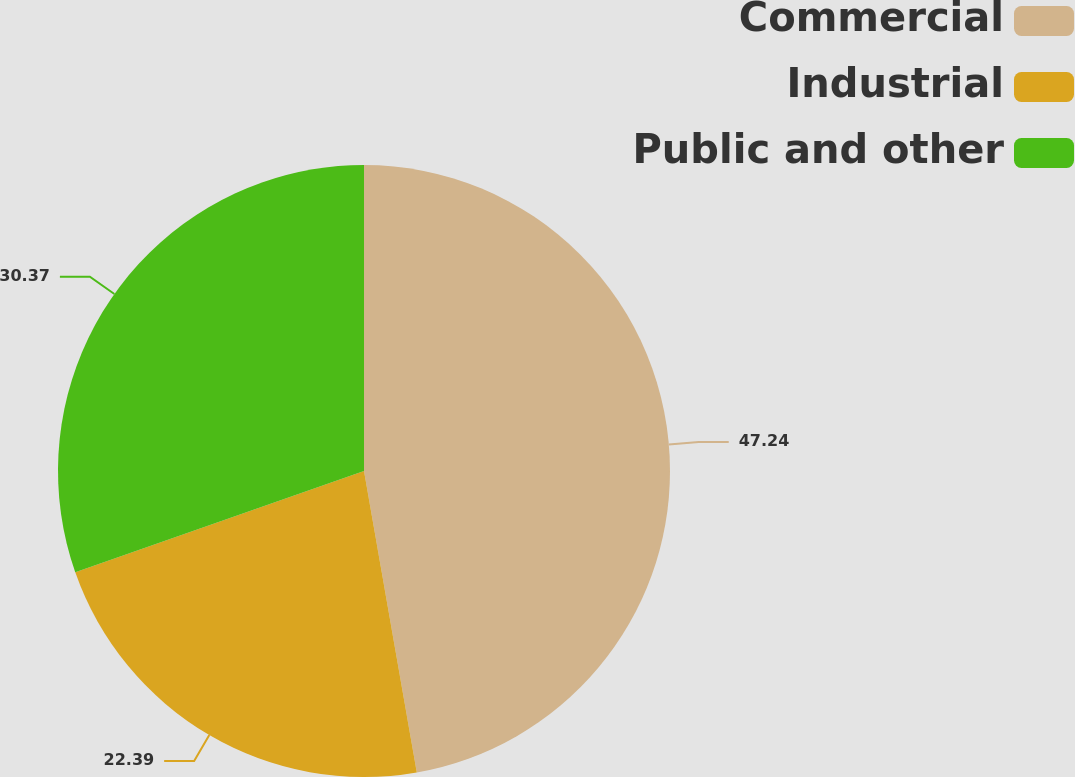<chart> <loc_0><loc_0><loc_500><loc_500><pie_chart><fcel>Commercial<fcel>Industrial<fcel>Public and other<nl><fcel>47.24%<fcel>22.39%<fcel>30.37%<nl></chart> 